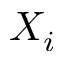Convert formula to latex. <formula><loc_0><loc_0><loc_500><loc_500>X _ { i }</formula> 